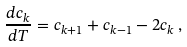<formula> <loc_0><loc_0><loc_500><loc_500>\frac { d c _ { k } } { d T } = c _ { k + 1 } + c _ { k - 1 } - 2 c _ { k } \, ,</formula> 